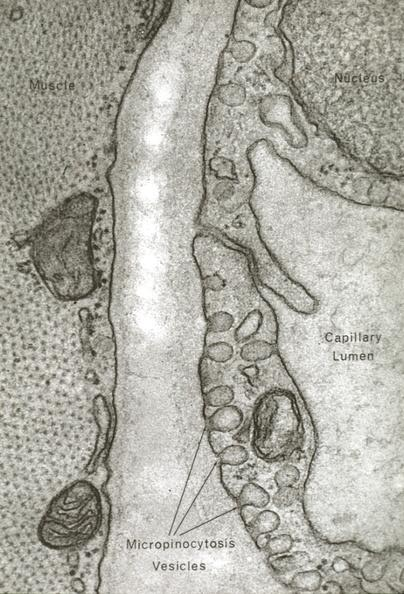s fibrinous peritonitis present?
Answer the question using a single word or phrase. No 